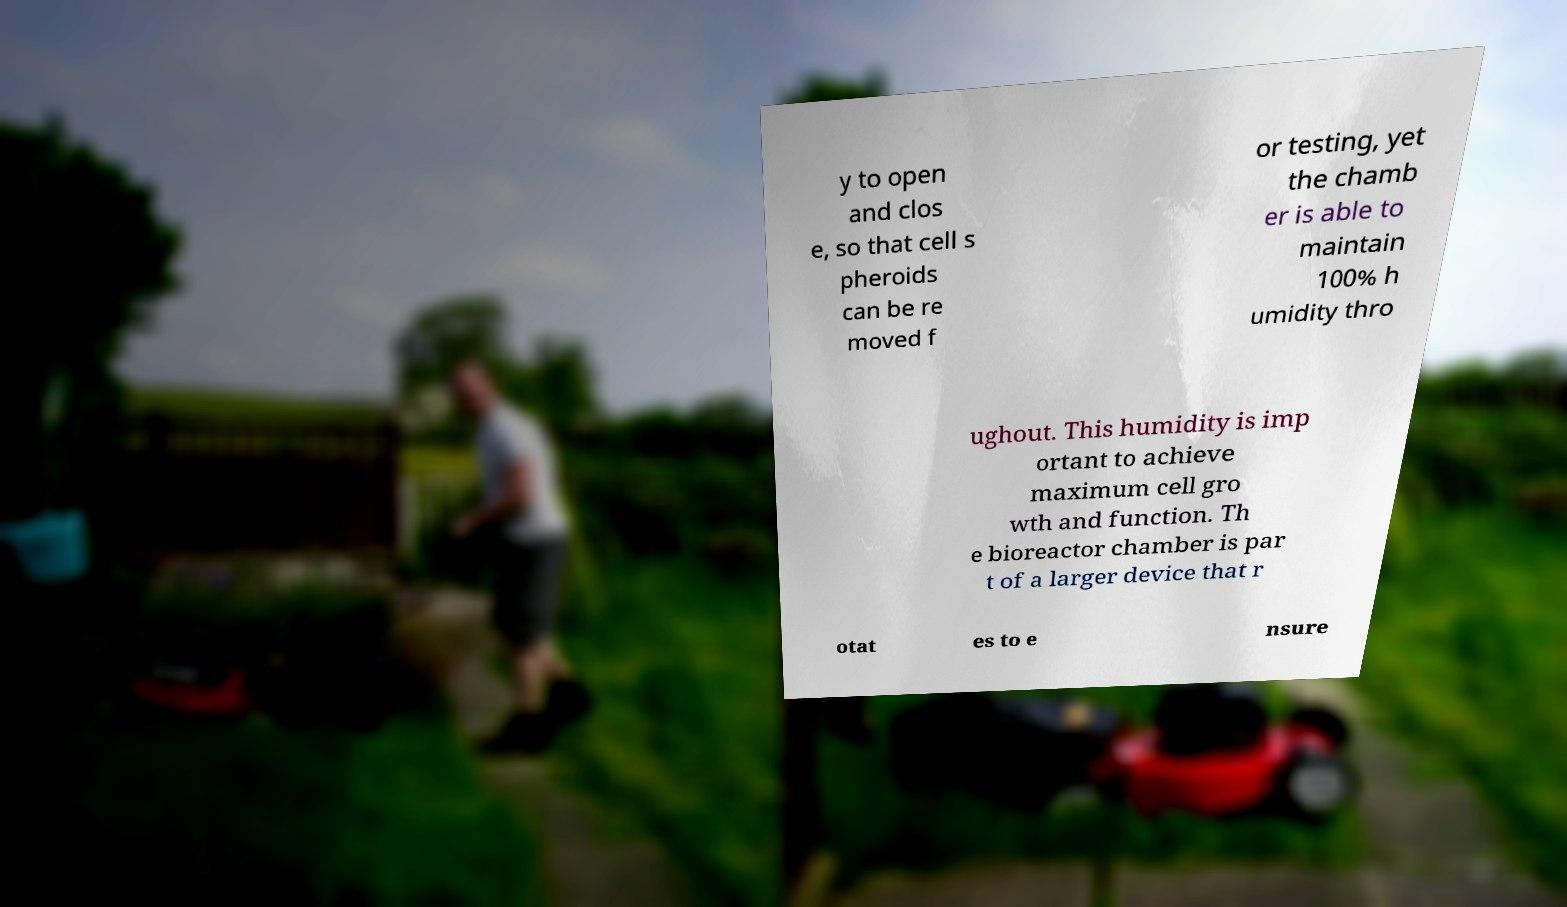Could you extract and type out the text from this image? y to open and clos e, so that cell s pheroids can be re moved f or testing, yet the chamb er is able to maintain 100% h umidity thro ughout. This humidity is imp ortant to achieve maximum cell gro wth and function. Th e bioreactor chamber is par t of a larger device that r otat es to e nsure 